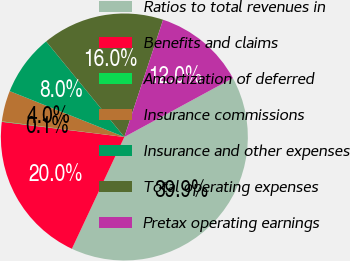Convert chart. <chart><loc_0><loc_0><loc_500><loc_500><pie_chart><fcel>Ratios to total revenues in<fcel>Benefits and claims<fcel>Amortization of deferred<fcel>Insurance commissions<fcel>Insurance and other expenses<fcel>Total operating expenses<fcel>Pretax operating earnings<nl><fcel>39.9%<fcel>19.98%<fcel>0.06%<fcel>4.04%<fcel>8.03%<fcel>15.99%<fcel>12.01%<nl></chart> 